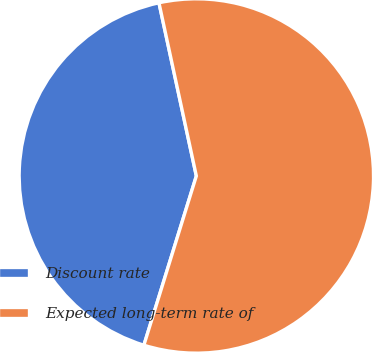<chart> <loc_0><loc_0><loc_500><loc_500><pie_chart><fcel>Discount rate<fcel>Expected long-term rate of<nl><fcel>41.83%<fcel>58.17%<nl></chart> 